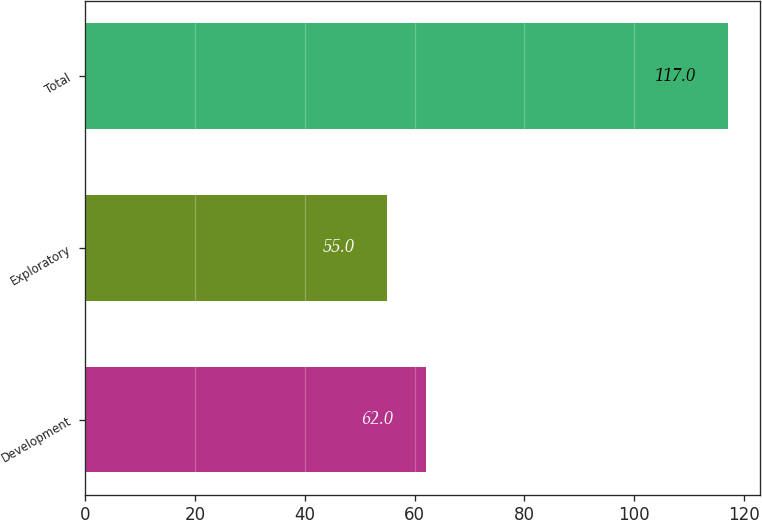Convert chart to OTSL. <chart><loc_0><loc_0><loc_500><loc_500><bar_chart><fcel>Development<fcel>Exploratory<fcel>Total<nl><fcel>62<fcel>55<fcel>117<nl></chart> 